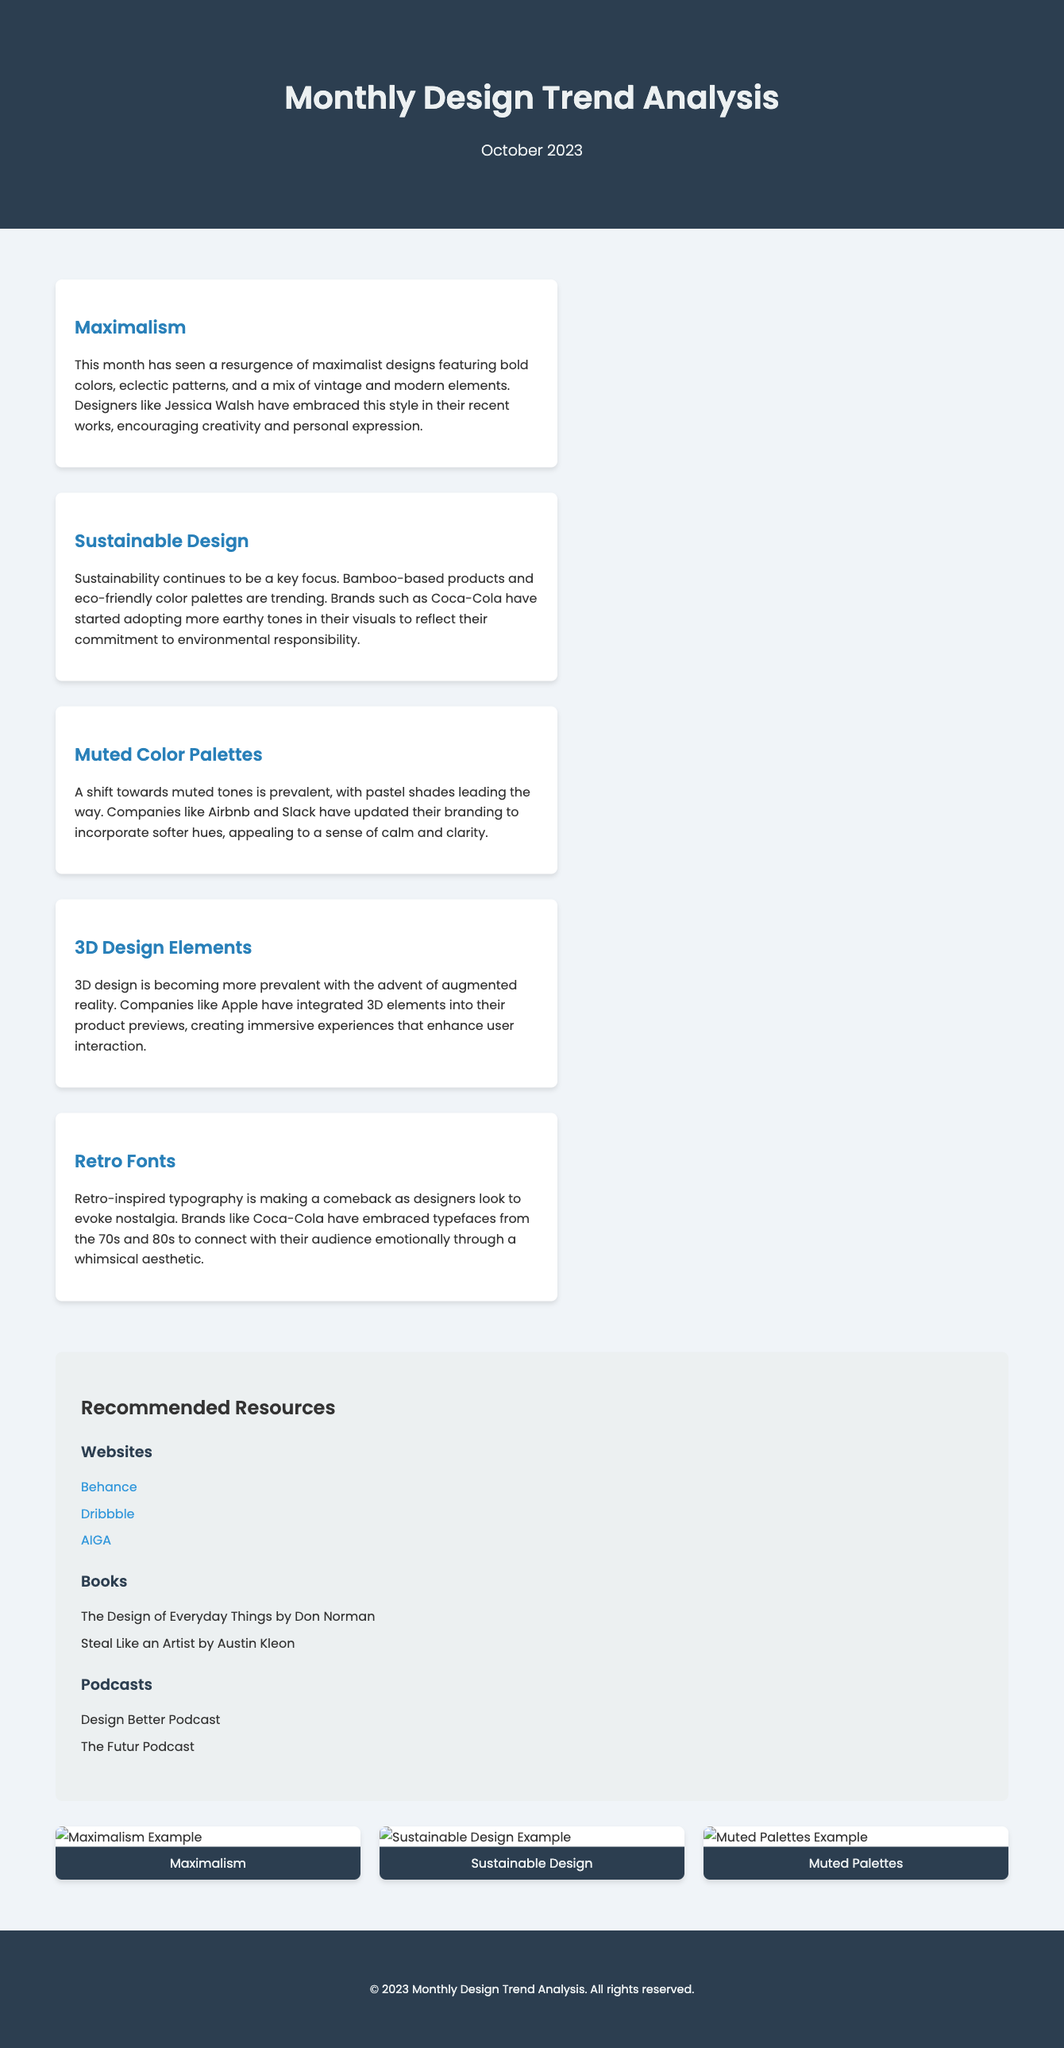what is the title of this report? The title is provided in the document's header section, indicating the subject matter and timeframe of the analysis.
Answer: Monthly Design Trend Analysis what is the focus of the first trend mentioned? The first trend card provides information specifically about the maximalist design style showcased in the analysis.
Answer: Maximalism which company is mentioned in context with sustainable design? The document references a company adopting this trend, demonstrating its commitment to eco-friendly practices.
Answer: Coca-Cola how many key trends are discussed in the report? The document includes a section listing and describing various design trends, which can be counted easily.
Answer: Five what color palettes are trending according to the report? The document specifically discusses the prevalent color schemes among companies in their branding updates.
Answer: Muted Color Palettes which design element is highlighted for enhancing user interaction? This design element is noted for its increasing relevance and application in modern interfaces, particularly by a leading tech brand.
Answer: 3D Design Elements name one of the recommended resources listed in the document. The resources are categorized, and the document outlines websites, books, and podcasts available for further learning.
Answer: Behance who is the author of the book "The Design of Everyday Things"? The document lists this book under recommended resources, with an indication of its author.
Answer: Don Norman what is a common characteristic of the retro fonts trend? The document describes this trend's emotional connection with the audience and its aesthetic influence in recent designs.
Answer: Nostalgia 